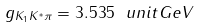Convert formula to latex. <formula><loc_0><loc_0><loc_500><loc_500>g _ { K _ { 1 } K ^ { * } \pi } = 3 . 5 3 5 \ u n i t { G e V }</formula> 